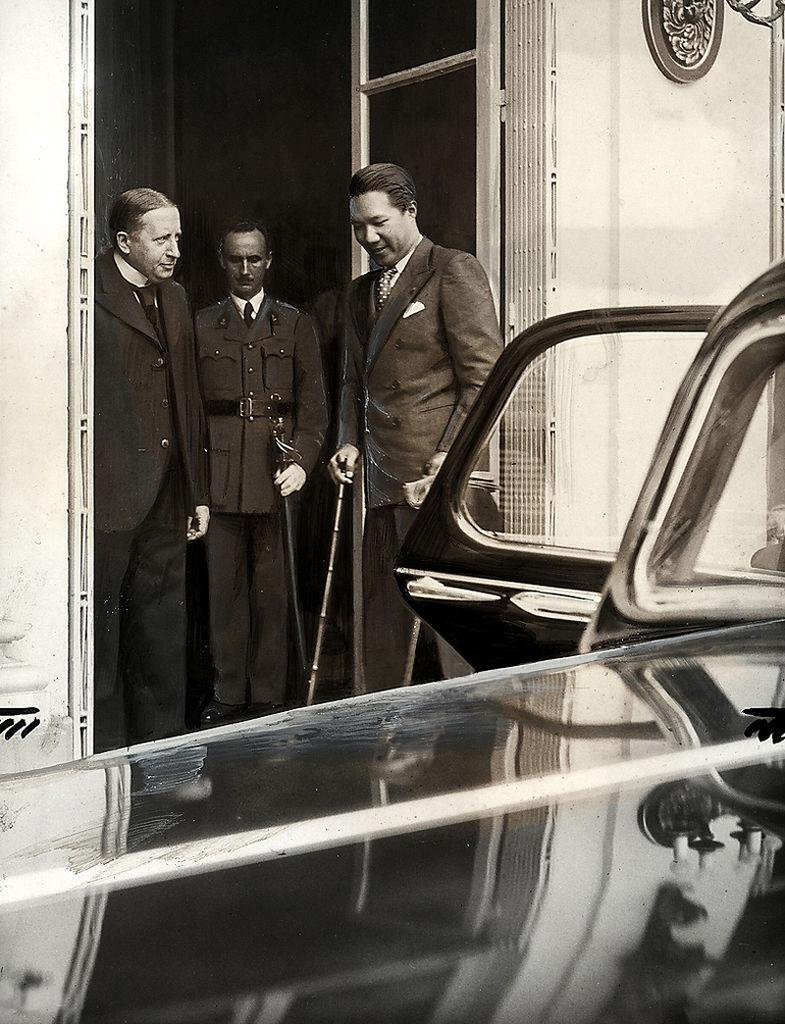What is the color scheme of the image? The image is black and white. What can be seen in the background of the image? There are three persons standing in front of a building door. What is located in the foreground of the image? There is a car in the foreground of the image. What type of pencil is being used by the persons in the image? There is no pencil present in the image; it is a black and white photograph of three persons standing in front of a building door and a car in the foreground. 